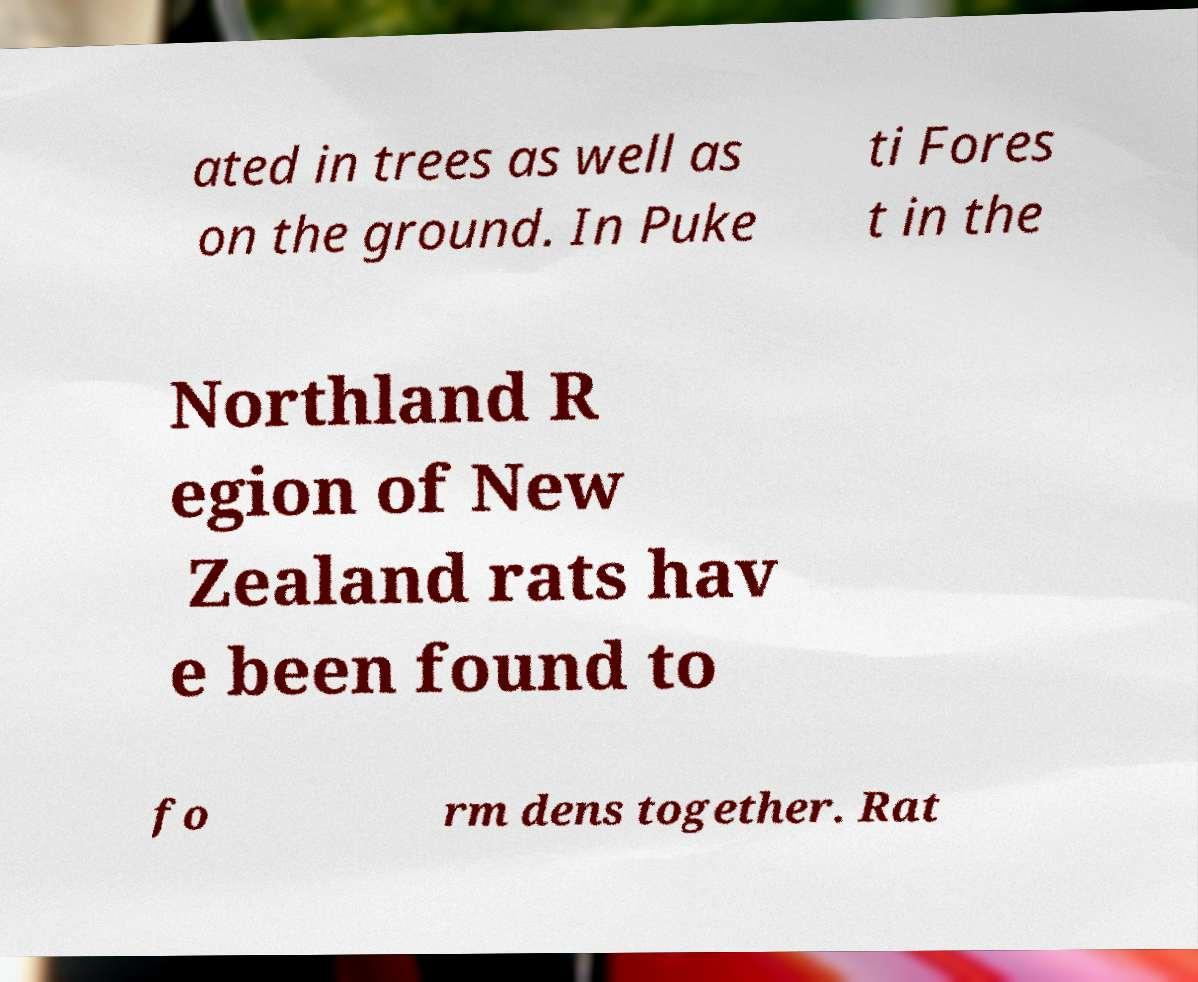Could you extract and type out the text from this image? ated in trees as well as on the ground. In Puke ti Fores t in the Northland R egion of New Zealand rats hav e been found to fo rm dens together. Rat 